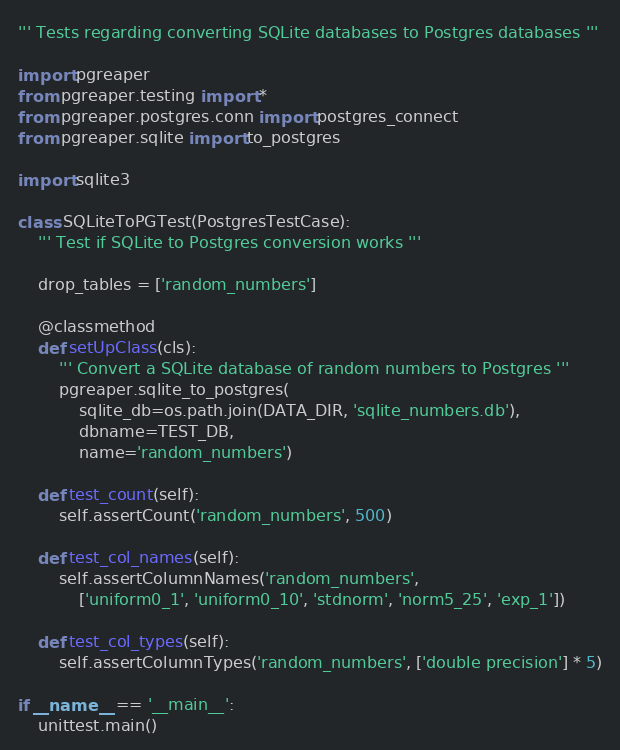Convert code to text. <code><loc_0><loc_0><loc_500><loc_500><_Python_>''' Tests regarding converting SQLite databases to Postgres databases '''

import pgreaper
from pgreaper.testing import *
from pgreaper.postgres.conn import postgres_connect
from pgreaper.sqlite import to_postgres

import sqlite3
            
class SQLiteToPGTest(PostgresTestCase):
    ''' Test if SQLite to Postgres conversion works '''
    
    drop_tables = ['random_numbers']
    
    @classmethod
    def setUpClass(cls):
        ''' Convert a SQLite database of random numbers to Postgres '''
        pgreaper.sqlite_to_postgres(
            sqlite_db=os.path.join(DATA_DIR, 'sqlite_numbers.db'),
            dbname=TEST_DB,
            name='random_numbers')
        
    def test_count(self):
        self.assertCount('random_numbers', 500)
        
    def test_col_names(self):
        self.assertColumnNames('random_numbers',
            ['uniform0_1', 'uniform0_10', 'stdnorm', 'norm5_25', 'exp_1'])
        
    def test_col_types(self):
        self.assertColumnTypes('random_numbers', ['double precision'] * 5)
            
if __name__ == '__main__':
    unittest.main()</code> 